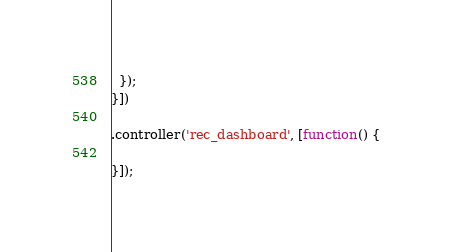<code> <loc_0><loc_0><loc_500><loc_500><_JavaScript_>  });
}])

.controller('rec_dashboard', [function() {

}]);</code> 